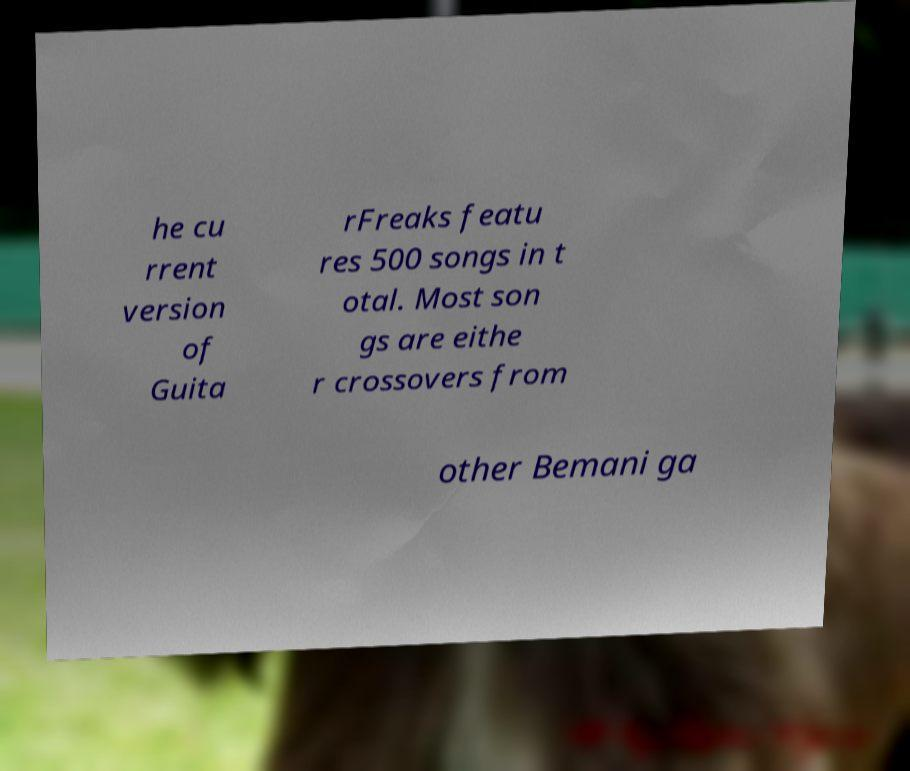Please identify and transcribe the text found in this image. he cu rrent version of Guita rFreaks featu res 500 songs in t otal. Most son gs are eithe r crossovers from other Bemani ga 